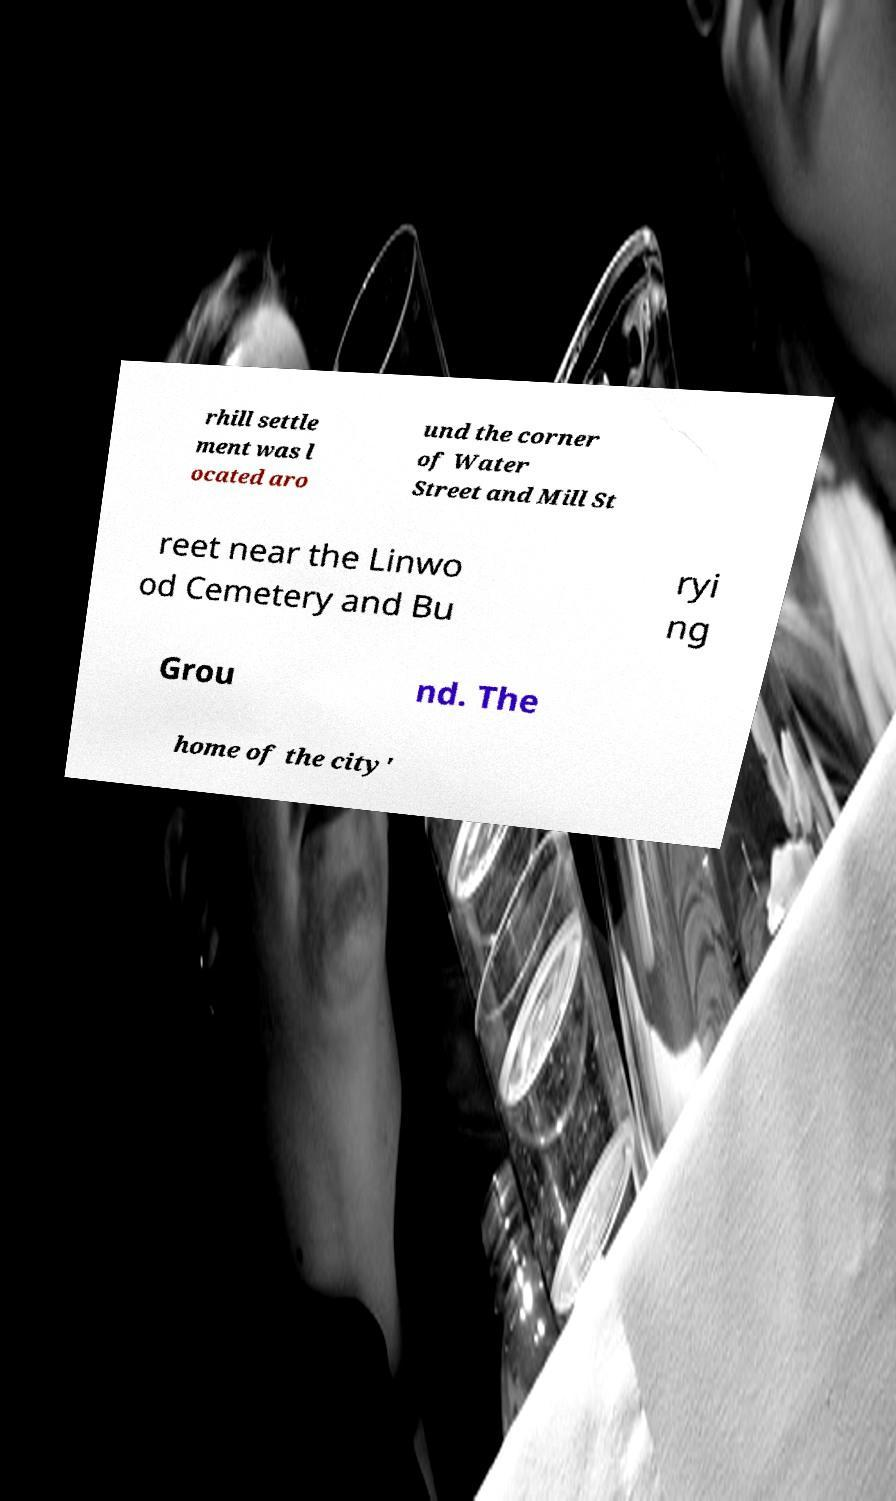Can you read and provide the text displayed in the image?This photo seems to have some interesting text. Can you extract and type it out for me? rhill settle ment was l ocated aro und the corner of Water Street and Mill St reet near the Linwo od Cemetery and Bu ryi ng Grou nd. The home of the city' 